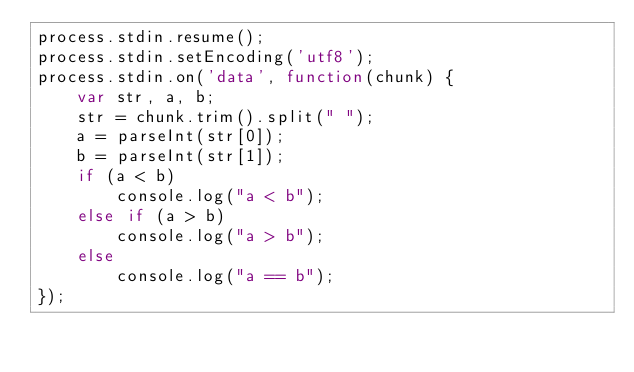<code> <loc_0><loc_0><loc_500><loc_500><_JavaScript_>process.stdin.resume();
process.stdin.setEncoding('utf8');
process.stdin.on('data', function(chunk) {
    var str, a, b;
    str = chunk.trim().split(" ");
    a = parseInt(str[0]);
    b = parseInt(str[1]);
    if (a < b)
        console.log("a < b");
    else if (a > b)
        console.log("a > b");
    else
        console.log("a == b");
});</code> 